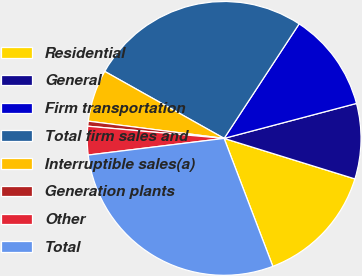<chart> <loc_0><loc_0><loc_500><loc_500><pie_chart><fcel>Residential<fcel>General<fcel>Firm transportation<fcel>Total firm sales and<fcel>Interruptible sales(a)<fcel>Generation plants<fcel>Other<fcel>Total<nl><fcel>14.43%<fcel>8.89%<fcel>11.66%<fcel>26.09%<fcel>6.13%<fcel>0.59%<fcel>3.36%<fcel>28.85%<nl></chart> 